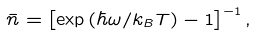<formula> <loc_0><loc_0><loc_500><loc_500>\bar { n } = \left [ \exp { ( \hbar { \omega } / k _ { B } T ) } - 1 \right ] ^ { - 1 } ,</formula> 